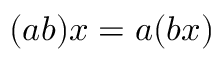<formula> <loc_0><loc_0><loc_500><loc_500>( a b ) x = a ( b x )</formula> 